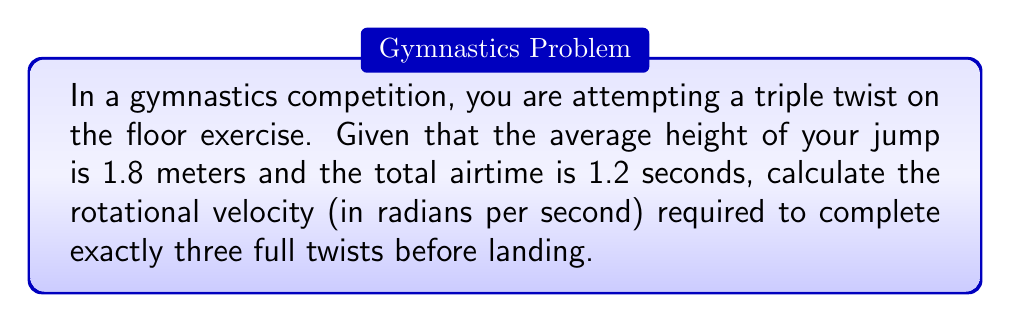Help me with this question. To solve this problem, we need to follow these steps:

1. Understand the given information:
   - Height of jump: $h = 1.8$ meters
   - Total airtime: $t = 1.2$ seconds
   - Number of twists: $n = 3$

2. Calculate the angular displacement:
   - One full twist is a rotation of $2\pi$ radians
   - For three twists, the total angular displacement is:
     $$\theta = 3 \cdot 2\pi = 6\pi \text{ radians}$$

3. Use the rotational kinematics equation:
   $$\theta = \omega t$$
   Where:
   - $\theta$ is the angular displacement (in radians)
   - $\omega$ is the rotational velocity (in radians per second)
   - $t$ is the time (in seconds)

4. Substitute the known values and solve for $\omega$:
   $$6\pi = \omega \cdot 1.2$$
   $$\omega = \frac{6\pi}{1.2} = 5\pi \text{ radians/second}$$

Thus, the required rotational velocity is $5\pi$ radians per second.

Note: In this calculation, we assumed a constant rotational velocity throughout the entire airtime. In reality, gymnasts may vary their rotational speed during different phases of the skill, but this simplification provides a good approximation for the average rotational velocity needed.
Answer: $5\pi \text{ radians/second}$ 